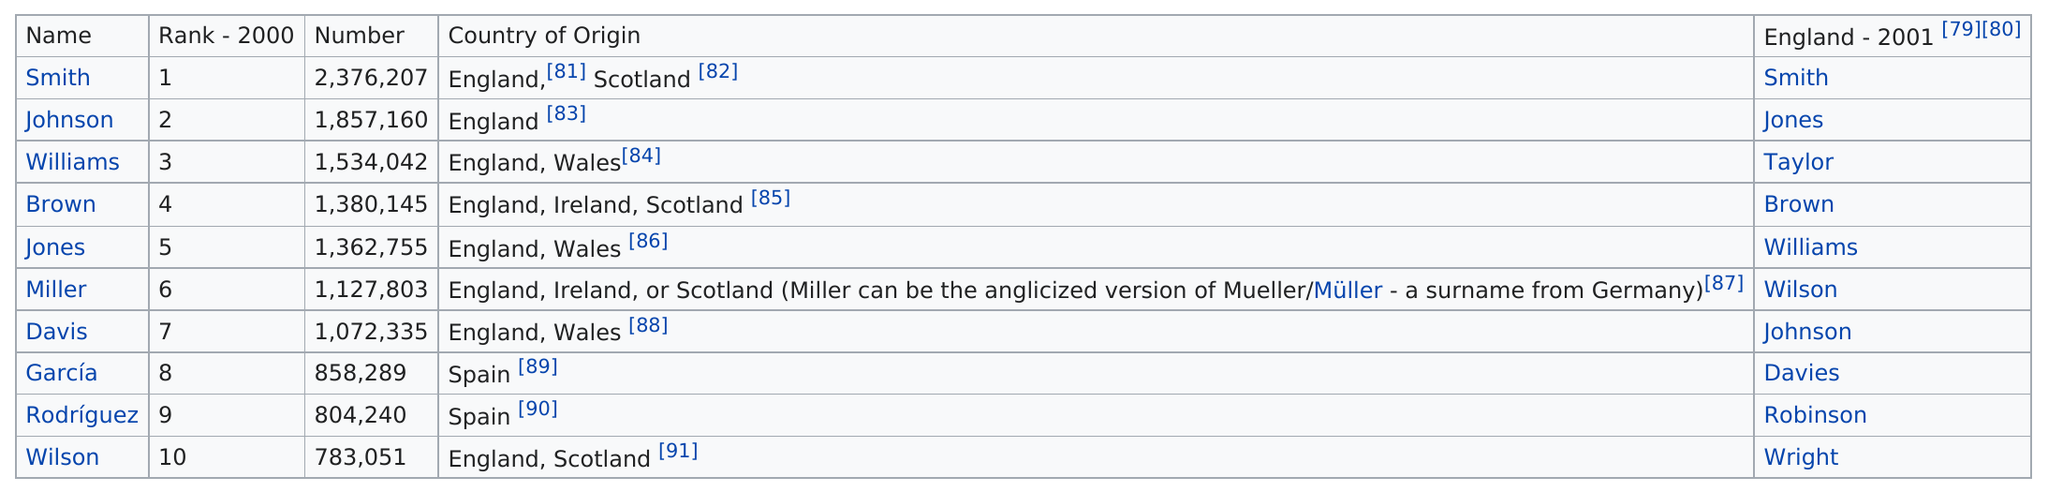Mention a couple of crucial points in this snapshot. The surname that belongs to the smallest number of people is Wilson. The fact that "brown" had a higher number than "Jones" is known. There were a total of 1,857,160 Johnsons. Smith is the English-American name that is most widely known and recognized by people around the world. García and Rodríguez are the only two names that originate from Spain. 